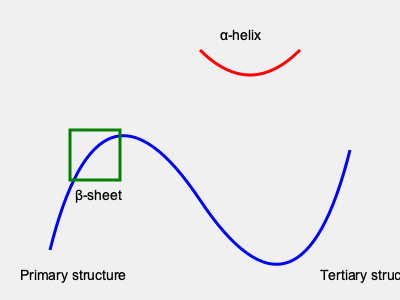In protein folding, which software tool is commonly used for visualizing and analyzing the 3D structure of proteins, and how does it contribute to understanding protein function? To answer this question, let's break down the process of protein structure visualization and analysis:

1. Importance of 3D structure:
   - Proteins' 3D structures determine their functions.
   - Visualization helps in understanding protein-protein interactions, active sites, and binding pockets.

2. Common software tool:
   - PyMOL is a widely used tool for protein structure visualization and analysis.

3. PyMOL's features:
   a) High-quality 3D rendering of protein structures
   b) Ability to highlight specific amino acids or regions
   c) Measurement tools for distances and angles
   d) Comparison of multiple structures
   e) Creation of publication-quality images

4. Contribution to understanding protein function:
   a) Identification of structural motifs (e.g., $\alpha$-helices, $\beta$-sheets)
   b) Visualization of ligand binding sites
   c) Analysis of protein-protein interaction interfaces
   d) Examination of conformational changes
   e) Identification of potential drug targets in structure-based drug design

5. Integration with other tools:
   - PyMOL can be scripted and integrated with other bioinformatics tools for comprehensive analysis.

By using PyMOL, molecular biologists can gain valuable insights into protein structure-function relationships, aiding in various research areas such as drug discovery, protein engineering, and understanding disease mechanisms.
Answer: PyMOL; visualizes 3D structures, enabling analysis of structural motifs, binding sites, and protein interactions. 